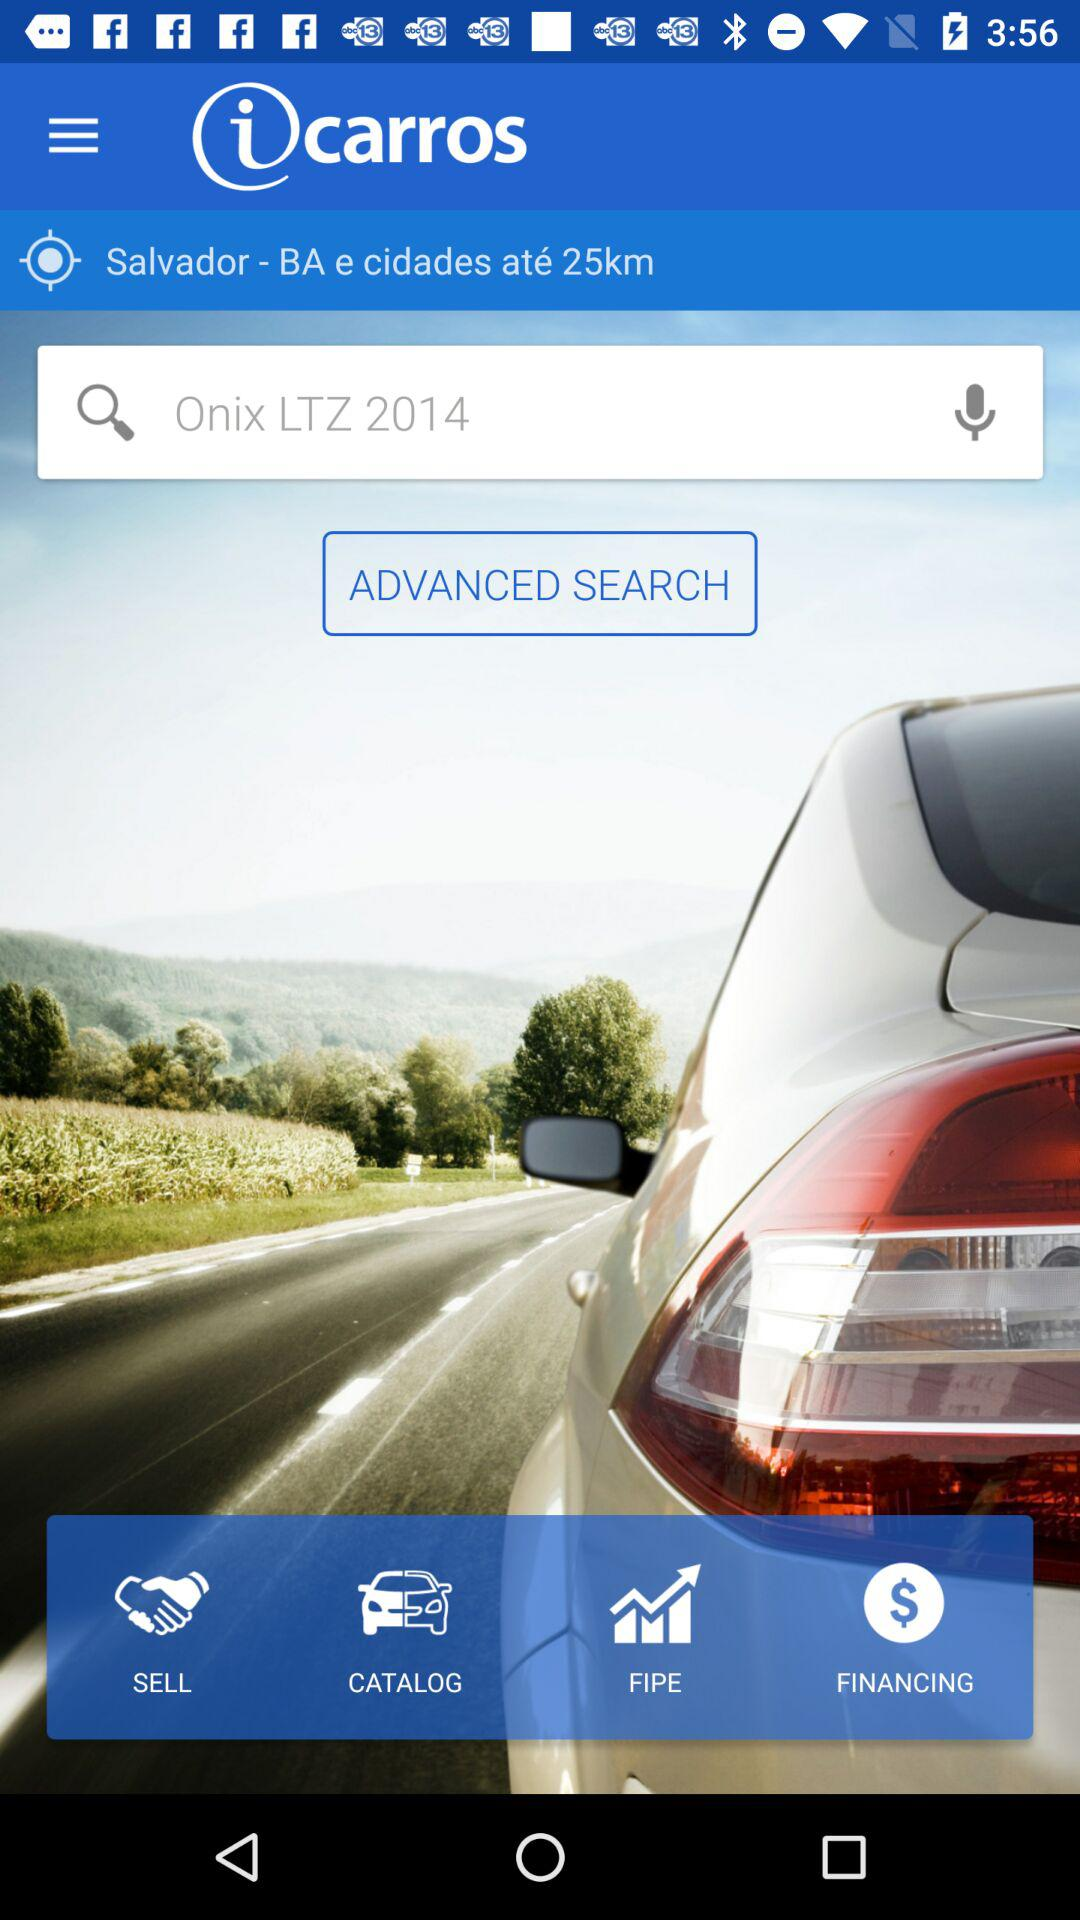What is the location? The location is Salvador. 